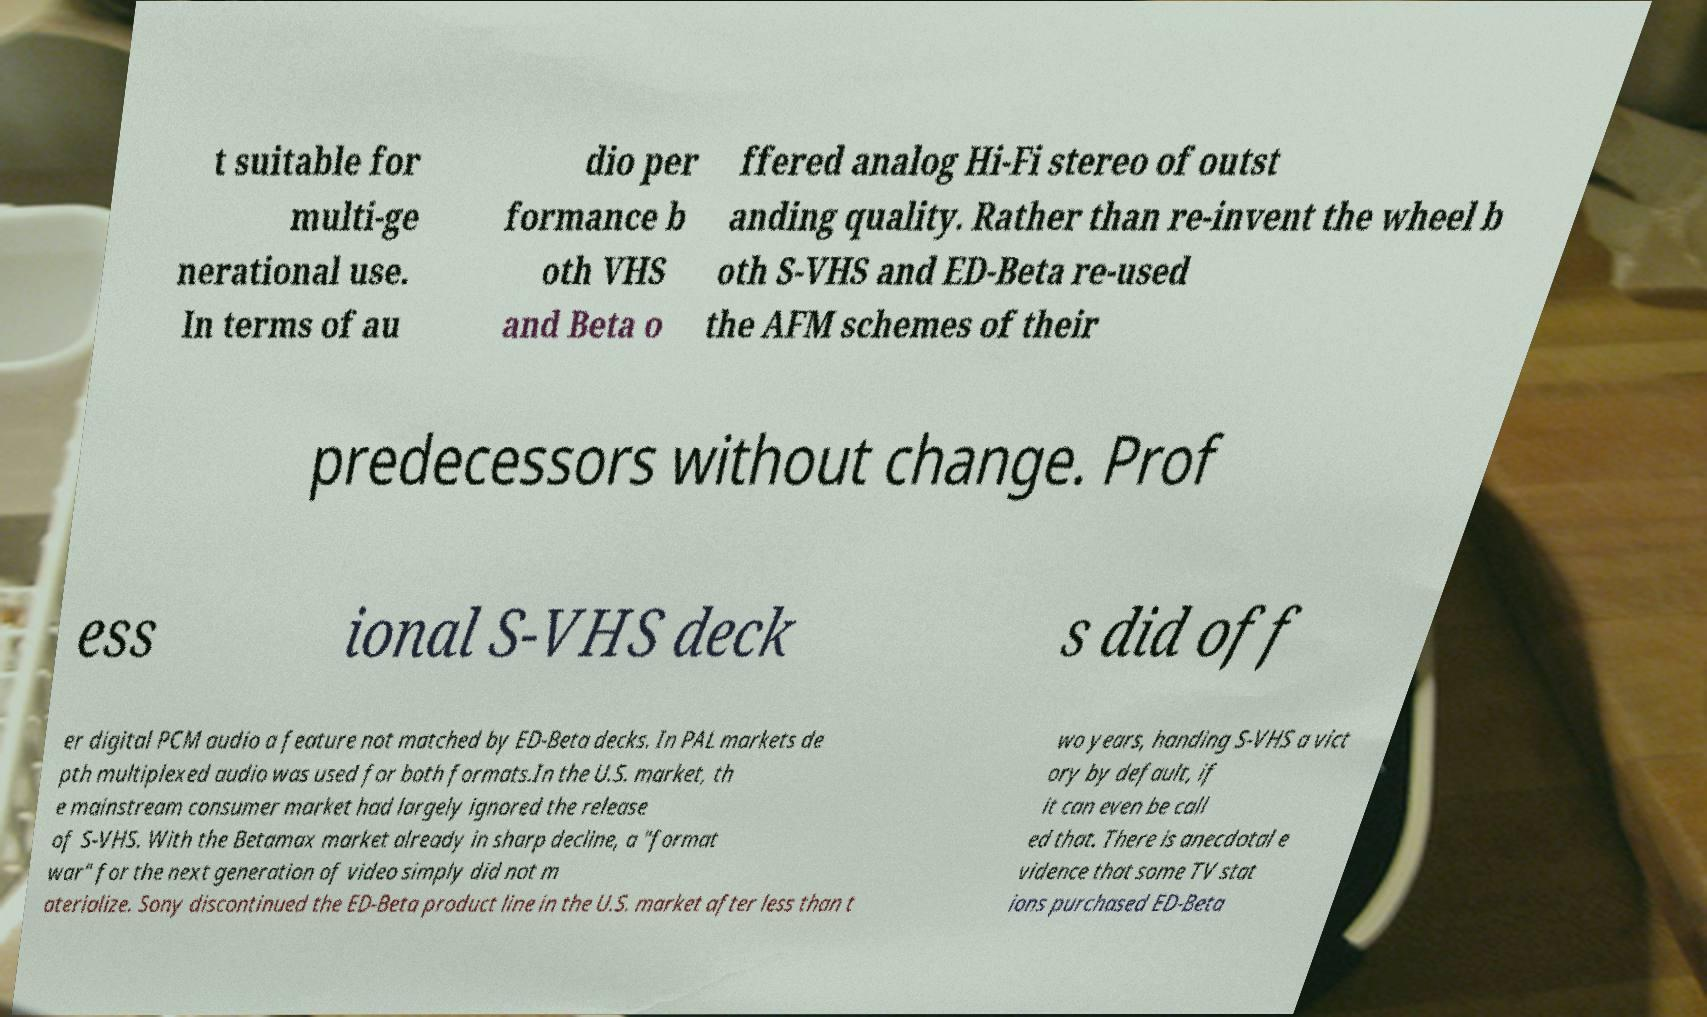Could you extract and type out the text from this image? t suitable for multi-ge nerational use. In terms of au dio per formance b oth VHS and Beta o ffered analog Hi-Fi stereo of outst anding quality. Rather than re-invent the wheel b oth S-VHS and ED-Beta re-used the AFM schemes of their predecessors without change. Prof ess ional S-VHS deck s did off er digital PCM audio a feature not matched by ED-Beta decks. In PAL markets de pth multiplexed audio was used for both formats.In the U.S. market, th e mainstream consumer market had largely ignored the release of S-VHS. With the Betamax market already in sharp decline, a "format war" for the next generation of video simply did not m aterialize. Sony discontinued the ED-Beta product line in the U.S. market after less than t wo years, handing S-VHS a vict ory by default, if it can even be call ed that. There is anecdotal e vidence that some TV stat ions purchased ED-Beta 